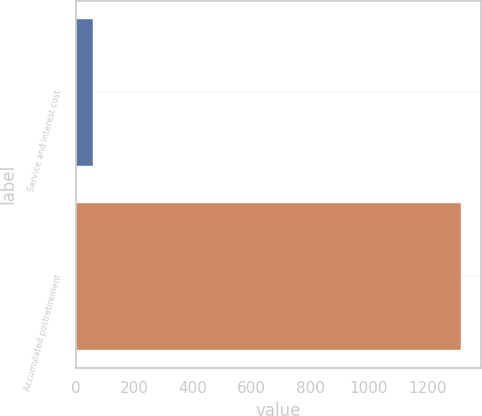Convert chart. <chart><loc_0><loc_0><loc_500><loc_500><bar_chart><fcel>Service and interest cost<fcel>Accumulated postretirement<nl><fcel>57<fcel>1316<nl></chart> 